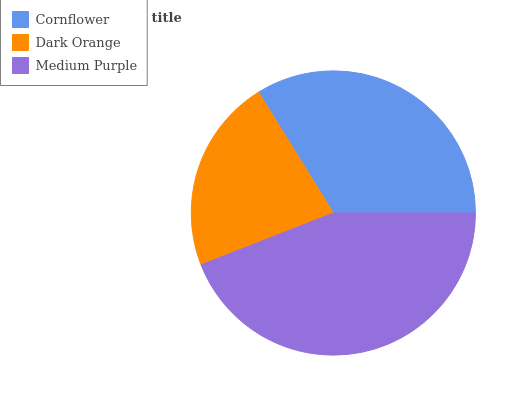Is Dark Orange the minimum?
Answer yes or no. Yes. Is Medium Purple the maximum?
Answer yes or no. Yes. Is Medium Purple the minimum?
Answer yes or no. No. Is Dark Orange the maximum?
Answer yes or no. No. Is Medium Purple greater than Dark Orange?
Answer yes or no. Yes. Is Dark Orange less than Medium Purple?
Answer yes or no. Yes. Is Dark Orange greater than Medium Purple?
Answer yes or no. No. Is Medium Purple less than Dark Orange?
Answer yes or no. No. Is Cornflower the high median?
Answer yes or no. Yes. Is Cornflower the low median?
Answer yes or no. Yes. Is Dark Orange the high median?
Answer yes or no. No. Is Dark Orange the low median?
Answer yes or no. No. 